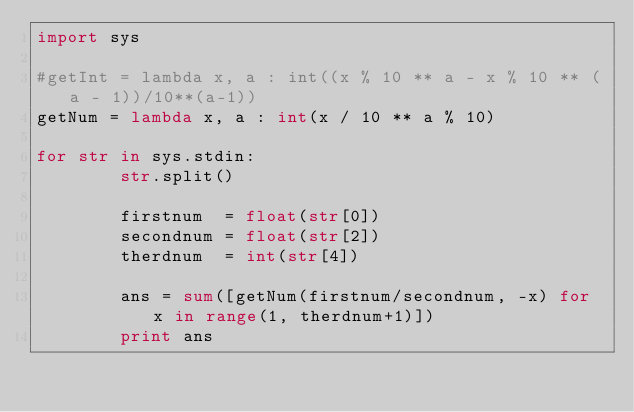Convert code to text. <code><loc_0><loc_0><loc_500><loc_500><_Python_>import sys

#getInt = lambda x, a : int((x % 10 ** a - x % 10 ** (a - 1))/10**(a-1))
getNum = lambda x, a : int(x / 10 ** a % 10)

for str in sys.stdin:
        str.split()

        firstnum  = float(str[0])
        secondnum = float(str[2])
        therdnum  = int(str[4])

        ans = sum([getNum(firstnum/secondnum, -x) for x in range(1, therdnum+1)])
        print ans</code> 